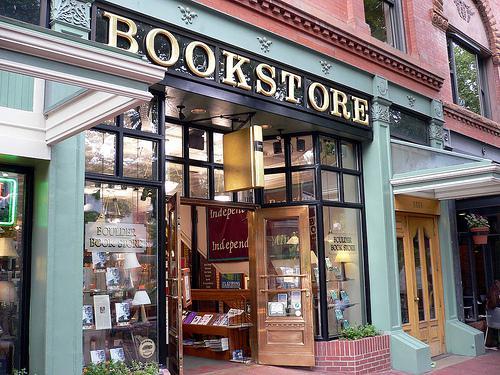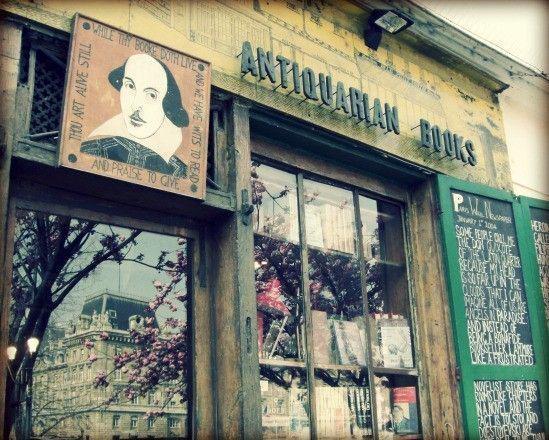The first image is the image on the left, the second image is the image on the right. For the images shown, is this caption "There are two bookstore storefronts." true? Answer yes or no. Yes. The first image is the image on the left, the second image is the image on the right. Considering the images on both sides, is "There are people in the image that are not indoors." valid? Answer yes or no. No. 